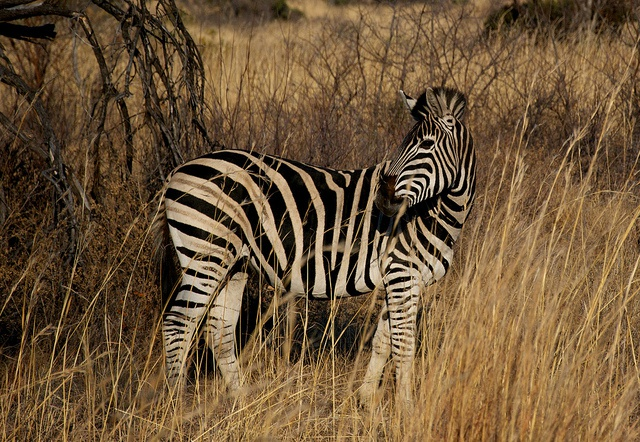Describe the objects in this image and their specific colors. I can see a zebra in black, tan, and gray tones in this image. 